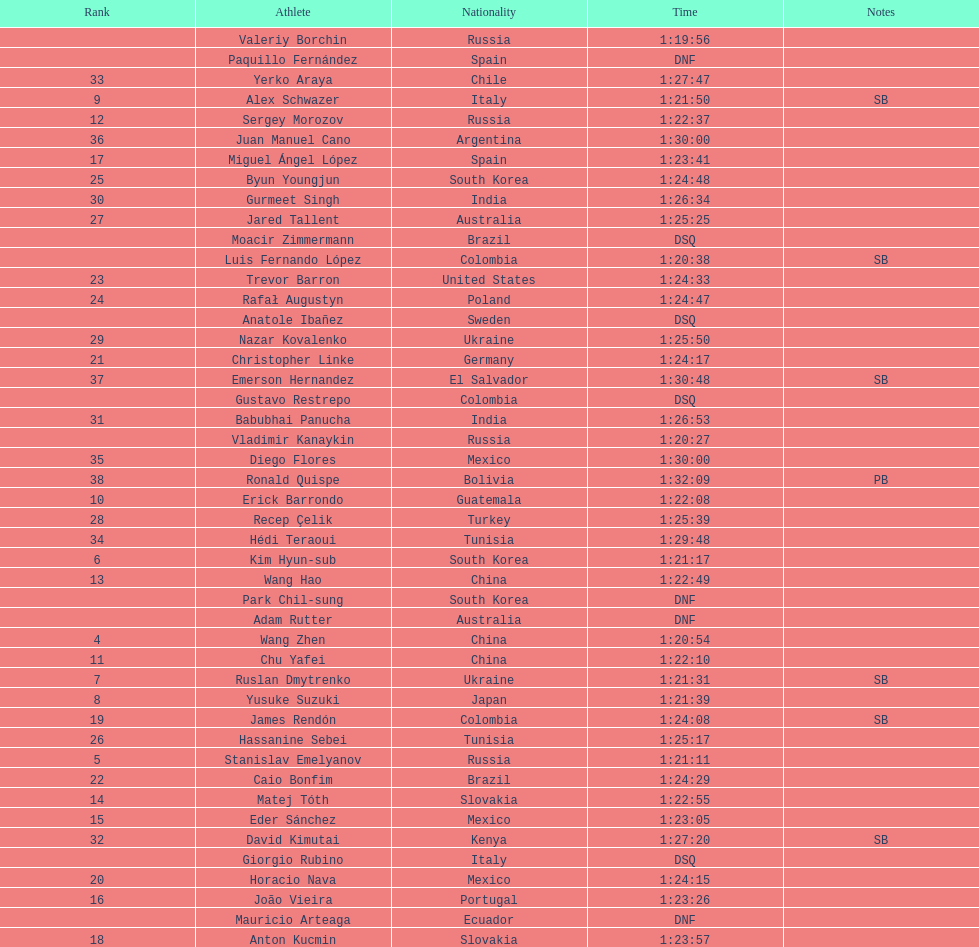Who placed in the top spot? Valeriy Borchin. 